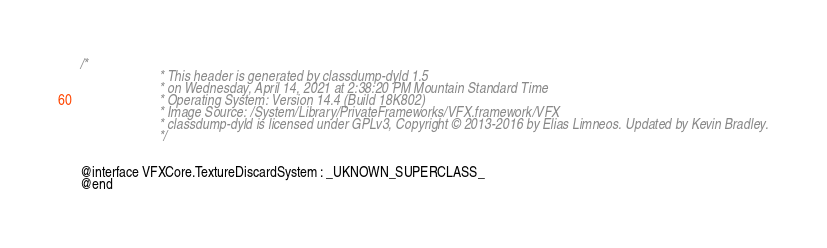Convert code to text. <code><loc_0><loc_0><loc_500><loc_500><_C_>/*
                       * This header is generated by classdump-dyld 1.5
                       * on Wednesday, April 14, 2021 at 2:38:20 PM Mountain Standard Time
                       * Operating System: Version 14.4 (Build 18K802)
                       * Image Source: /System/Library/PrivateFrameworks/VFX.framework/VFX
                       * classdump-dyld is licensed under GPLv3, Copyright © 2013-2016 by Elias Limneos. Updated by Kevin Bradley.
                       */


@interface VFXCore.TextureDiscardSystem : _UKNOWN_SUPERCLASS_
@end

</code> 